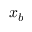Convert formula to latex. <formula><loc_0><loc_0><loc_500><loc_500>x _ { b }</formula> 